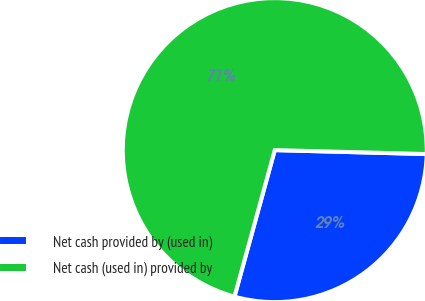Convert chart. <chart><loc_0><loc_0><loc_500><loc_500><pie_chart><fcel>Net cash provided by (used in)<fcel>Net cash (used in) provided by<nl><fcel>28.86%<fcel>71.14%<nl></chart> 